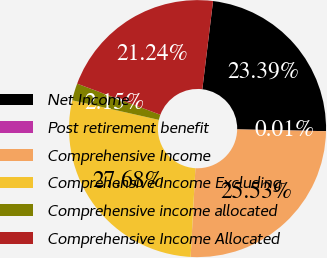Convert chart to OTSL. <chart><loc_0><loc_0><loc_500><loc_500><pie_chart><fcel>Net Income<fcel>Post retirement benefit<fcel>Comprehensive Income<fcel>Comprehensive Income Excluding<fcel>Comprehensive income allocated<fcel>Comprehensive Income Allocated<nl><fcel>23.39%<fcel>0.01%<fcel>25.53%<fcel>27.68%<fcel>2.15%<fcel>21.24%<nl></chart> 